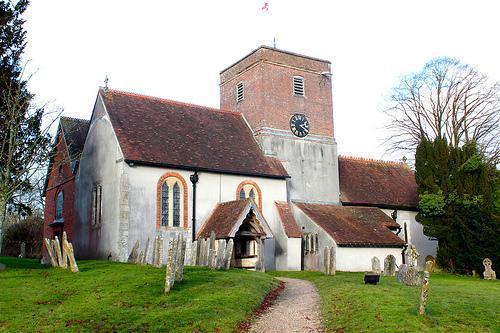How many buildings are there?
Give a very brief answer. 1. 